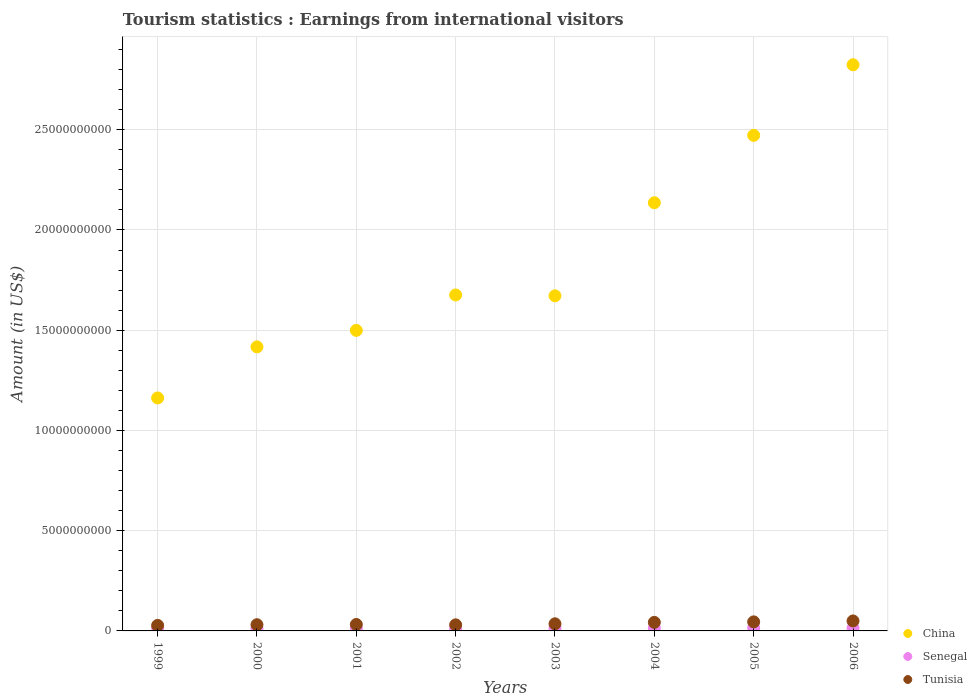How many different coloured dotlines are there?
Provide a succinct answer. 3. What is the earnings from international visitors in Tunisia in 2004?
Make the answer very short. 4.27e+08. Across all years, what is the maximum earnings from international visitors in China?
Your answer should be very brief. 2.82e+1. Across all years, what is the minimum earnings from international visitors in Tunisia?
Give a very brief answer. 2.76e+08. In which year was the earnings from international visitors in China maximum?
Your response must be concise. 2006. What is the total earnings from international visitors in China in the graph?
Give a very brief answer. 1.49e+11. What is the difference between the earnings from international visitors in Tunisia in 2000 and that in 2006?
Give a very brief answer. -1.88e+08. What is the difference between the earnings from international visitors in Tunisia in 2004 and the earnings from international visitors in Senegal in 2001?
Ensure brevity in your answer.  3.15e+08. What is the average earnings from international visitors in China per year?
Offer a terse response. 1.86e+1. In the year 2002, what is the difference between the earnings from international visitors in Tunisia and earnings from international visitors in Senegal?
Ensure brevity in your answer.  1.91e+08. In how many years, is the earnings from international visitors in China greater than 25000000000 US$?
Your answer should be very brief. 1. What is the ratio of the earnings from international visitors in Tunisia in 2001 to that in 2004?
Provide a short and direct response. 0.75. What is the difference between the highest and the second highest earnings from international visitors in Tunisia?
Make the answer very short. 4.60e+07. What is the difference between the highest and the lowest earnings from international visitors in China?
Your answer should be very brief. 1.66e+1. Does the earnings from international visitors in Senegal monotonically increase over the years?
Offer a very short reply. No. Is the earnings from international visitors in China strictly greater than the earnings from international visitors in Tunisia over the years?
Ensure brevity in your answer.  Yes. Is the earnings from international visitors in China strictly less than the earnings from international visitors in Senegal over the years?
Give a very brief answer. No. How many years are there in the graph?
Ensure brevity in your answer.  8. Does the graph contain grids?
Offer a very short reply. Yes. How many legend labels are there?
Give a very brief answer. 3. How are the legend labels stacked?
Your response must be concise. Vertical. What is the title of the graph?
Provide a short and direct response. Tourism statistics : Earnings from international visitors. What is the Amount (in US$) in China in 1999?
Your answer should be very brief. 1.16e+1. What is the Amount (in US$) of Senegal in 1999?
Your answer should be compact. 1.36e+08. What is the Amount (in US$) of Tunisia in 1999?
Provide a short and direct response. 2.76e+08. What is the Amount (in US$) of China in 2000?
Keep it short and to the point. 1.42e+1. What is the Amount (in US$) in Senegal in 2000?
Offer a terse response. 1.25e+08. What is the Amount (in US$) of Tunisia in 2000?
Make the answer very short. 3.10e+08. What is the Amount (in US$) of China in 2001?
Offer a very short reply. 1.50e+1. What is the Amount (in US$) in Senegal in 2001?
Ensure brevity in your answer.  1.12e+08. What is the Amount (in US$) of Tunisia in 2001?
Provide a short and direct response. 3.22e+08. What is the Amount (in US$) of China in 2002?
Provide a succinct answer. 1.68e+1. What is the Amount (in US$) in Senegal in 2002?
Make the answer very short. 1.12e+08. What is the Amount (in US$) of Tunisia in 2002?
Keep it short and to the point. 3.03e+08. What is the Amount (in US$) in China in 2003?
Keep it short and to the point. 1.67e+1. What is the Amount (in US$) of Senegal in 2003?
Ensure brevity in your answer.  1.29e+08. What is the Amount (in US$) of Tunisia in 2003?
Make the answer very short. 3.55e+08. What is the Amount (in US$) in China in 2004?
Your response must be concise. 2.14e+1. What is the Amount (in US$) in Senegal in 2004?
Provide a succinct answer. 1.38e+08. What is the Amount (in US$) of Tunisia in 2004?
Your response must be concise. 4.27e+08. What is the Amount (in US$) of China in 2005?
Ensure brevity in your answer.  2.47e+1. What is the Amount (in US$) of Senegal in 2005?
Your answer should be very brief. 1.44e+08. What is the Amount (in US$) in Tunisia in 2005?
Your answer should be very brief. 4.52e+08. What is the Amount (in US$) of China in 2006?
Give a very brief answer. 2.82e+1. What is the Amount (in US$) in Senegal in 2006?
Ensure brevity in your answer.  1.39e+08. What is the Amount (in US$) in Tunisia in 2006?
Your answer should be very brief. 4.98e+08. Across all years, what is the maximum Amount (in US$) in China?
Offer a very short reply. 2.82e+1. Across all years, what is the maximum Amount (in US$) of Senegal?
Offer a terse response. 1.44e+08. Across all years, what is the maximum Amount (in US$) in Tunisia?
Offer a terse response. 4.98e+08. Across all years, what is the minimum Amount (in US$) of China?
Offer a terse response. 1.16e+1. Across all years, what is the minimum Amount (in US$) in Senegal?
Your answer should be very brief. 1.12e+08. Across all years, what is the minimum Amount (in US$) of Tunisia?
Your answer should be very brief. 2.76e+08. What is the total Amount (in US$) of China in the graph?
Your response must be concise. 1.49e+11. What is the total Amount (in US$) in Senegal in the graph?
Give a very brief answer. 1.04e+09. What is the total Amount (in US$) of Tunisia in the graph?
Provide a short and direct response. 2.94e+09. What is the difference between the Amount (in US$) of China in 1999 and that in 2000?
Your response must be concise. -2.55e+09. What is the difference between the Amount (in US$) in Senegal in 1999 and that in 2000?
Your response must be concise. 1.10e+07. What is the difference between the Amount (in US$) of Tunisia in 1999 and that in 2000?
Your answer should be very brief. -3.40e+07. What is the difference between the Amount (in US$) in China in 1999 and that in 2001?
Your response must be concise. -3.37e+09. What is the difference between the Amount (in US$) of Senegal in 1999 and that in 2001?
Offer a terse response. 2.40e+07. What is the difference between the Amount (in US$) in Tunisia in 1999 and that in 2001?
Ensure brevity in your answer.  -4.60e+07. What is the difference between the Amount (in US$) of China in 1999 and that in 2002?
Your answer should be compact. -5.14e+09. What is the difference between the Amount (in US$) of Senegal in 1999 and that in 2002?
Offer a very short reply. 2.40e+07. What is the difference between the Amount (in US$) of Tunisia in 1999 and that in 2002?
Keep it short and to the point. -2.70e+07. What is the difference between the Amount (in US$) of China in 1999 and that in 2003?
Ensure brevity in your answer.  -5.10e+09. What is the difference between the Amount (in US$) in Tunisia in 1999 and that in 2003?
Keep it short and to the point. -7.90e+07. What is the difference between the Amount (in US$) of China in 1999 and that in 2004?
Your answer should be very brief. -9.74e+09. What is the difference between the Amount (in US$) of Tunisia in 1999 and that in 2004?
Provide a succinct answer. -1.51e+08. What is the difference between the Amount (in US$) in China in 1999 and that in 2005?
Give a very brief answer. -1.31e+1. What is the difference between the Amount (in US$) of Senegal in 1999 and that in 2005?
Offer a very short reply. -8.00e+06. What is the difference between the Amount (in US$) of Tunisia in 1999 and that in 2005?
Your answer should be very brief. -1.76e+08. What is the difference between the Amount (in US$) of China in 1999 and that in 2006?
Provide a short and direct response. -1.66e+1. What is the difference between the Amount (in US$) in Tunisia in 1999 and that in 2006?
Offer a very short reply. -2.22e+08. What is the difference between the Amount (in US$) in China in 2000 and that in 2001?
Offer a terse response. -8.23e+08. What is the difference between the Amount (in US$) in Senegal in 2000 and that in 2001?
Provide a succinct answer. 1.30e+07. What is the difference between the Amount (in US$) in Tunisia in 2000 and that in 2001?
Provide a succinct answer. -1.20e+07. What is the difference between the Amount (in US$) in China in 2000 and that in 2002?
Your answer should be compact. -2.59e+09. What is the difference between the Amount (in US$) of Senegal in 2000 and that in 2002?
Ensure brevity in your answer.  1.30e+07. What is the difference between the Amount (in US$) of Tunisia in 2000 and that in 2002?
Make the answer very short. 7.00e+06. What is the difference between the Amount (in US$) of China in 2000 and that in 2003?
Provide a short and direct response. -2.55e+09. What is the difference between the Amount (in US$) in Tunisia in 2000 and that in 2003?
Ensure brevity in your answer.  -4.50e+07. What is the difference between the Amount (in US$) in China in 2000 and that in 2004?
Offer a very short reply. -7.19e+09. What is the difference between the Amount (in US$) in Senegal in 2000 and that in 2004?
Offer a very short reply. -1.30e+07. What is the difference between the Amount (in US$) in Tunisia in 2000 and that in 2004?
Provide a succinct answer. -1.17e+08. What is the difference between the Amount (in US$) in China in 2000 and that in 2005?
Ensure brevity in your answer.  -1.06e+1. What is the difference between the Amount (in US$) in Senegal in 2000 and that in 2005?
Keep it short and to the point. -1.90e+07. What is the difference between the Amount (in US$) of Tunisia in 2000 and that in 2005?
Your response must be concise. -1.42e+08. What is the difference between the Amount (in US$) of China in 2000 and that in 2006?
Provide a succinct answer. -1.41e+1. What is the difference between the Amount (in US$) in Senegal in 2000 and that in 2006?
Your answer should be very brief. -1.40e+07. What is the difference between the Amount (in US$) in Tunisia in 2000 and that in 2006?
Provide a short and direct response. -1.88e+08. What is the difference between the Amount (in US$) in China in 2001 and that in 2002?
Offer a very short reply. -1.77e+09. What is the difference between the Amount (in US$) in Tunisia in 2001 and that in 2002?
Make the answer very short. 1.90e+07. What is the difference between the Amount (in US$) in China in 2001 and that in 2003?
Provide a succinct answer. -1.72e+09. What is the difference between the Amount (in US$) of Senegal in 2001 and that in 2003?
Keep it short and to the point. -1.70e+07. What is the difference between the Amount (in US$) of Tunisia in 2001 and that in 2003?
Provide a short and direct response. -3.30e+07. What is the difference between the Amount (in US$) of China in 2001 and that in 2004?
Provide a short and direct response. -6.37e+09. What is the difference between the Amount (in US$) of Senegal in 2001 and that in 2004?
Your answer should be very brief. -2.60e+07. What is the difference between the Amount (in US$) in Tunisia in 2001 and that in 2004?
Your response must be concise. -1.05e+08. What is the difference between the Amount (in US$) of China in 2001 and that in 2005?
Offer a very short reply. -9.73e+09. What is the difference between the Amount (in US$) in Senegal in 2001 and that in 2005?
Provide a short and direct response. -3.20e+07. What is the difference between the Amount (in US$) of Tunisia in 2001 and that in 2005?
Provide a succinct answer. -1.30e+08. What is the difference between the Amount (in US$) of China in 2001 and that in 2006?
Your answer should be very brief. -1.32e+1. What is the difference between the Amount (in US$) in Senegal in 2001 and that in 2006?
Keep it short and to the point. -2.70e+07. What is the difference between the Amount (in US$) of Tunisia in 2001 and that in 2006?
Provide a succinct answer. -1.76e+08. What is the difference between the Amount (in US$) of China in 2002 and that in 2003?
Offer a very short reply. 4.30e+07. What is the difference between the Amount (in US$) of Senegal in 2002 and that in 2003?
Provide a succinct answer. -1.70e+07. What is the difference between the Amount (in US$) in Tunisia in 2002 and that in 2003?
Your answer should be very brief. -5.20e+07. What is the difference between the Amount (in US$) of China in 2002 and that in 2004?
Provide a succinct answer. -4.60e+09. What is the difference between the Amount (in US$) of Senegal in 2002 and that in 2004?
Keep it short and to the point. -2.60e+07. What is the difference between the Amount (in US$) of Tunisia in 2002 and that in 2004?
Give a very brief answer. -1.24e+08. What is the difference between the Amount (in US$) in China in 2002 and that in 2005?
Offer a very short reply. -7.96e+09. What is the difference between the Amount (in US$) in Senegal in 2002 and that in 2005?
Offer a very short reply. -3.20e+07. What is the difference between the Amount (in US$) of Tunisia in 2002 and that in 2005?
Keep it short and to the point. -1.49e+08. What is the difference between the Amount (in US$) of China in 2002 and that in 2006?
Offer a terse response. -1.15e+1. What is the difference between the Amount (in US$) of Senegal in 2002 and that in 2006?
Offer a terse response. -2.70e+07. What is the difference between the Amount (in US$) in Tunisia in 2002 and that in 2006?
Give a very brief answer. -1.95e+08. What is the difference between the Amount (in US$) in China in 2003 and that in 2004?
Give a very brief answer. -4.64e+09. What is the difference between the Amount (in US$) in Senegal in 2003 and that in 2004?
Offer a terse response. -9.00e+06. What is the difference between the Amount (in US$) in Tunisia in 2003 and that in 2004?
Your answer should be very brief. -7.20e+07. What is the difference between the Amount (in US$) in China in 2003 and that in 2005?
Provide a short and direct response. -8.00e+09. What is the difference between the Amount (in US$) in Senegal in 2003 and that in 2005?
Your answer should be very brief. -1.50e+07. What is the difference between the Amount (in US$) in Tunisia in 2003 and that in 2005?
Provide a short and direct response. -9.70e+07. What is the difference between the Amount (in US$) in China in 2003 and that in 2006?
Provide a short and direct response. -1.15e+1. What is the difference between the Amount (in US$) in Senegal in 2003 and that in 2006?
Your answer should be very brief. -1.00e+07. What is the difference between the Amount (in US$) in Tunisia in 2003 and that in 2006?
Provide a succinct answer. -1.43e+08. What is the difference between the Amount (in US$) in China in 2004 and that in 2005?
Provide a succinct answer. -3.36e+09. What is the difference between the Amount (in US$) in Senegal in 2004 and that in 2005?
Provide a succinct answer. -6.00e+06. What is the difference between the Amount (in US$) in Tunisia in 2004 and that in 2005?
Ensure brevity in your answer.  -2.50e+07. What is the difference between the Amount (in US$) of China in 2004 and that in 2006?
Give a very brief answer. -6.88e+09. What is the difference between the Amount (in US$) in Tunisia in 2004 and that in 2006?
Offer a terse response. -7.10e+07. What is the difference between the Amount (in US$) in China in 2005 and that in 2006?
Your answer should be very brief. -3.52e+09. What is the difference between the Amount (in US$) of Senegal in 2005 and that in 2006?
Give a very brief answer. 5.00e+06. What is the difference between the Amount (in US$) in Tunisia in 2005 and that in 2006?
Your answer should be very brief. -4.60e+07. What is the difference between the Amount (in US$) of China in 1999 and the Amount (in US$) of Senegal in 2000?
Offer a terse response. 1.15e+1. What is the difference between the Amount (in US$) of China in 1999 and the Amount (in US$) of Tunisia in 2000?
Your answer should be compact. 1.13e+1. What is the difference between the Amount (in US$) of Senegal in 1999 and the Amount (in US$) of Tunisia in 2000?
Provide a short and direct response. -1.74e+08. What is the difference between the Amount (in US$) of China in 1999 and the Amount (in US$) of Senegal in 2001?
Offer a very short reply. 1.15e+1. What is the difference between the Amount (in US$) of China in 1999 and the Amount (in US$) of Tunisia in 2001?
Your answer should be very brief. 1.13e+1. What is the difference between the Amount (in US$) of Senegal in 1999 and the Amount (in US$) of Tunisia in 2001?
Offer a terse response. -1.86e+08. What is the difference between the Amount (in US$) in China in 1999 and the Amount (in US$) in Senegal in 2002?
Offer a terse response. 1.15e+1. What is the difference between the Amount (in US$) of China in 1999 and the Amount (in US$) of Tunisia in 2002?
Keep it short and to the point. 1.13e+1. What is the difference between the Amount (in US$) in Senegal in 1999 and the Amount (in US$) in Tunisia in 2002?
Ensure brevity in your answer.  -1.67e+08. What is the difference between the Amount (in US$) of China in 1999 and the Amount (in US$) of Senegal in 2003?
Your answer should be very brief. 1.15e+1. What is the difference between the Amount (in US$) of China in 1999 and the Amount (in US$) of Tunisia in 2003?
Offer a very short reply. 1.13e+1. What is the difference between the Amount (in US$) of Senegal in 1999 and the Amount (in US$) of Tunisia in 2003?
Provide a short and direct response. -2.19e+08. What is the difference between the Amount (in US$) in China in 1999 and the Amount (in US$) in Senegal in 2004?
Provide a short and direct response. 1.15e+1. What is the difference between the Amount (in US$) in China in 1999 and the Amount (in US$) in Tunisia in 2004?
Provide a short and direct response. 1.12e+1. What is the difference between the Amount (in US$) of Senegal in 1999 and the Amount (in US$) of Tunisia in 2004?
Your answer should be very brief. -2.91e+08. What is the difference between the Amount (in US$) of China in 1999 and the Amount (in US$) of Senegal in 2005?
Offer a very short reply. 1.15e+1. What is the difference between the Amount (in US$) in China in 1999 and the Amount (in US$) in Tunisia in 2005?
Provide a succinct answer. 1.12e+1. What is the difference between the Amount (in US$) of Senegal in 1999 and the Amount (in US$) of Tunisia in 2005?
Ensure brevity in your answer.  -3.16e+08. What is the difference between the Amount (in US$) in China in 1999 and the Amount (in US$) in Senegal in 2006?
Offer a terse response. 1.15e+1. What is the difference between the Amount (in US$) of China in 1999 and the Amount (in US$) of Tunisia in 2006?
Offer a very short reply. 1.11e+1. What is the difference between the Amount (in US$) in Senegal in 1999 and the Amount (in US$) in Tunisia in 2006?
Your answer should be very brief. -3.62e+08. What is the difference between the Amount (in US$) in China in 2000 and the Amount (in US$) in Senegal in 2001?
Provide a succinct answer. 1.41e+1. What is the difference between the Amount (in US$) in China in 2000 and the Amount (in US$) in Tunisia in 2001?
Offer a very short reply. 1.38e+1. What is the difference between the Amount (in US$) in Senegal in 2000 and the Amount (in US$) in Tunisia in 2001?
Your response must be concise. -1.97e+08. What is the difference between the Amount (in US$) in China in 2000 and the Amount (in US$) in Senegal in 2002?
Offer a very short reply. 1.41e+1. What is the difference between the Amount (in US$) of China in 2000 and the Amount (in US$) of Tunisia in 2002?
Your answer should be very brief. 1.39e+1. What is the difference between the Amount (in US$) in Senegal in 2000 and the Amount (in US$) in Tunisia in 2002?
Your response must be concise. -1.78e+08. What is the difference between the Amount (in US$) in China in 2000 and the Amount (in US$) in Senegal in 2003?
Your answer should be compact. 1.40e+1. What is the difference between the Amount (in US$) of China in 2000 and the Amount (in US$) of Tunisia in 2003?
Keep it short and to the point. 1.38e+1. What is the difference between the Amount (in US$) of Senegal in 2000 and the Amount (in US$) of Tunisia in 2003?
Your response must be concise. -2.30e+08. What is the difference between the Amount (in US$) of China in 2000 and the Amount (in US$) of Senegal in 2004?
Make the answer very short. 1.40e+1. What is the difference between the Amount (in US$) in China in 2000 and the Amount (in US$) in Tunisia in 2004?
Your answer should be very brief. 1.37e+1. What is the difference between the Amount (in US$) in Senegal in 2000 and the Amount (in US$) in Tunisia in 2004?
Give a very brief answer. -3.02e+08. What is the difference between the Amount (in US$) of China in 2000 and the Amount (in US$) of Senegal in 2005?
Make the answer very short. 1.40e+1. What is the difference between the Amount (in US$) in China in 2000 and the Amount (in US$) in Tunisia in 2005?
Provide a succinct answer. 1.37e+1. What is the difference between the Amount (in US$) of Senegal in 2000 and the Amount (in US$) of Tunisia in 2005?
Your answer should be compact. -3.27e+08. What is the difference between the Amount (in US$) in China in 2000 and the Amount (in US$) in Senegal in 2006?
Make the answer very short. 1.40e+1. What is the difference between the Amount (in US$) of China in 2000 and the Amount (in US$) of Tunisia in 2006?
Give a very brief answer. 1.37e+1. What is the difference between the Amount (in US$) in Senegal in 2000 and the Amount (in US$) in Tunisia in 2006?
Your answer should be very brief. -3.73e+08. What is the difference between the Amount (in US$) in China in 2001 and the Amount (in US$) in Senegal in 2002?
Provide a short and direct response. 1.49e+1. What is the difference between the Amount (in US$) in China in 2001 and the Amount (in US$) in Tunisia in 2002?
Make the answer very short. 1.47e+1. What is the difference between the Amount (in US$) of Senegal in 2001 and the Amount (in US$) of Tunisia in 2002?
Make the answer very short. -1.91e+08. What is the difference between the Amount (in US$) in China in 2001 and the Amount (in US$) in Senegal in 2003?
Make the answer very short. 1.49e+1. What is the difference between the Amount (in US$) in China in 2001 and the Amount (in US$) in Tunisia in 2003?
Provide a succinct answer. 1.46e+1. What is the difference between the Amount (in US$) in Senegal in 2001 and the Amount (in US$) in Tunisia in 2003?
Ensure brevity in your answer.  -2.43e+08. What is the difference between the Amount (in US$) in China in 2001 and the Amount (in US$) in Senegal in 2004?
Provide a succinct answer. 1.49e+1. What is the difference between the Amount (in US$) of China in 2001 and the Amount (in US$) of Tunisia in 2004?
Keep it short and to the point. 1.46e+1. What is the difference between the Amount (in US$) of Senegal in 2001 and the Amount (in US$) of Tunisia in 2004?
Make the answer very short. -3.15e+08. What is the difference between the Amount (in US$) in China in 2001 and the Amount (in US$) in Senegal in 2005?
Provide a succinct answer. 1.48e+1. What is the difference between the Amount (in US$) in China in 2001 and the Amount (in US$) in Tunisia in 2005?
Provide a succinct answer. 1.45e+1. What is the difference between the Amount (in US$) in Senegal in 2001 and the Amount (in US$) in Tunisia in 2005?
Your answer should be very brief. -3.40e+08. What is the difference between the Amount (in US$) in China in 2001 and the Amount (in US$) in Senegal in 2006?
Provide a short and direct response. 1.49e+1. What is the difference between the Amount (in US$) of China in 2001 and the Amount (in US$) of Tunisia in 2006?
Make the answer very short. 1.45e+1. What is the difference between the Amount (in US$) of Senegal in 2001 and the Amount (in US$) of Tunisia in 2006?
Your response must be concise. -3.86e+08. What is the difference between the Amount (in US$) in China in 2002 and the Amount (in US$) in Senegal in 2003?
Your response must be concise. 1.66e+1. What is the difference between the Amount (in US$) of China in 2002 and the Amount (in US$) of Tunisia in 2003?
Keep it short and to the point. 1.64e+1. What is the difference between the Amount (in US$) in Senegal in 2002 and the Amount (in US$) in Tunisia in 2003?
Your answer should be compact. -2.43e+08. What is the difference between the Amount (in US$) of China in 2002 and the Amount (in US$) of Senegal in 2004?
Provide a short and direct response. 1.66e+1. What is the difference between the Amount (in US$) of China in 2002 and the Amount (in US$) of Tunisia in 2004?
Keep it short and to the point. 1.63e+1. What is the difference between the Amount (in US$) of Senegal in 2002 and the Amount (in US$) of Tunisia in 2004?
Your answer should be very brief. -3.15e+08. What is the difference between the Amount (in US$) of China in 2002 and the Amount (in US$) of Senegal in 2005?
Your answer should be very brief. 1.66e+1. What is the difference between the Amount (in US$) of China in 2002 and the Amount (in US$) of Tunisia in 2005?
Your response must be concise. 1.63e+1. What is the difference between the Amount (in US$) of Senegal in 2002 and the Amount (in US$) of Tunisia in 2005?
Your response must be concise. -3.40e+08. What is the difference between the Amount (in US$) in China in 2002 and the Amount (in US$) in Senegal in 2006?
Your answer should be very brief. 1.66e+1. What is the difference between the Amount (in US$) of China in 2002 and the Amount (in US$) of Tunisia in 2006?
Your answer should be very brief. 1.63e+1. What is the difference between the Amount (in US$) in Senegal in 2002 and the Amount (in US$) in Tunisia in 2006?
Make the answer very short. -3.86e+08. What is the difference between the Amount (in US$) in China in 2003 and the Amount (in US$) in Senegal in 2004?
Your answer should be very brief. 1.66e+1. What is the difference between the Amount (in US$) of China in 2003 and the Amount (in US$) of Tunisia in 2004?
Provide a short and direct response. 1.63e+1. What is the difference between the Amount (in US$) of Senegal in 2003 and the Amount (in US$) of Tunisia in 2004?
Keep it short and to the point. -2.98e+08. What is the difference between the Amount (in US$) of China in 2003 and the Amount (in US$) of Senegal in 2005?
Offer a very short reply. 1.66e+1. What is the difference between the Amount (in US$) of China in 2003 and the Amount (in US$) of Tunisia in 2005?
Give a very brief answer. 1.63e+1. What is the difference between the Amount (in US$) of Senegal in 2003 and the Amount (in US$) of Tunisia in 2005?
Offer a terse response. -3.23e+08. What is the difference between the Amount (in US$) of China in 2003 and the Amount (in US$) of Senegal in 2006?
Give a very brief answer. 1.66e+1. What is the difference between the Amount (in US$) of China in 2003 and the Amount (in US$) of Tunisia in 2006?
Your response must be concise. 1.62e+1. What is the difference between the Amount (in US$) in Senegal in 2003 and the Amount (in US$) in Tunisia in 2006?
Your response must be concise. -3.69e+08. What is the difference between the Amount (in US$) in China in 2004 and the Amount (in US$) in Senegal in 2005?
Your answer should be compact. 2.12e+1. What is the difference between the Amount (in US$) of China in 2004 and the Amount (in US$) of Tunisia in 2005?
Provide a succinct answer. 2.09e+1. What is the difference between the Amount (in US$) of Senegal in 2004 and the Amount (in US$) of Tunisia in 2005?
Make the answer very short. -3.14e+08. What is the difference between the Amount (in US$) in China in 2004 and the Amount (in US$) in Senegal in 2006?
Provide a succinct answer. 2.12e+1. What is the difference between the Amount (in US$) in China in 2004 and the Amount (in US$) in Tunisia in 2006?
Your response must be concise. 2.09e+1. What is the difference between the Amount (in US$) of Senegal in 2004 and the Amount (in US$) of Tunisia in 2006?
Offer a very short reply. -3.60e+08. What is the difference between the Amount (in US$) in China in 2005 and the Amount (in US$) in Senegal in 2006?
Your response must be concise. 2.46e+1. What is the difference between the Amount (in US$) in China in 2005 and the Amount (in US$) in Tunisia in 2006?
Your answer should be compact. 2.42e+1. What is the difference between the Amount (in US$) of Senegal in 2005 and the Amount (in US$) of Tunisia in 2006?
Your answer should be compact. -3.54e+08. What is the average Amount (in US$) of China per year?
Your answer should be very brief. 1.86e+1. What is the average Amount (in US$) in Senegal per year?
Provide a succinct answer. 1.29e+08. What is the average Amount (in US$) of Tunisia per year?
Offer a terse response. 3.68e+08. In the year 1999, what is the difference between the Amount (in US$) of China and Amount (in US$) of Senegal?
Ensure brevity in your answer.  1.15e+1. In the year 1999, what is the difference between the Amount (in US$) of China and Amount (in US$) of Tunisia?
Offer a very short reply. 1.13e+1. In the year 1999, what is the difference between the Amount (in US$) of Senegal and Amount (in US$) of Tunisia?
Offer a terse response. -1.40e+08. In the year 2000, what is the difference between the Amount (in US$) in China and Amount (in US$) in Senegal?
Keep it short and to the point. 1.40e+1. In the year 2000, what is the difference between the Amount (in US$) of China and Amount (in US$) of Tunisia?
Ensure brevity in your answer.  1.39e+1. In the year 2000, what is the difference between the Amount (in US$) of Senegal and Amount (in US$) of Tunisia?
Make the answer very short. -1.85e+08. In the year 2001, what is the difference between the Amount (in US$) in China and Amount (in US$) in Senegal?
Ensure brevity in your answer.  1.49e+1. In the year 2001, what is the difference between the Amount (in US$) of China and Amount (in US$) of Tunisia?
Ensure brevity in your answer.  1.47e+1. In the year 2001, what is the difference between the Amount (in US$) in Senegal and Amount (in US$) in Tunisia?
Ensure brevity in your answer.  -2.10e+08. In the year 2002, what is the difference between the Amount (in US$) in China and Amount (in US$) in Senegal?
Offer a very short reply. 1.66e+1. In the year 2002, what is the difference between the Amount (in US$) in China and Amount (in US$) in Tunisia?
Offer a very short reply. 1.65e+1. In the year 2002, what is the difference between the Amount (in US$) of Senegal and Amount (in US$) of Tunisia?
Give a very brief answer. -1.91e+08. In the year 2003, what is the difference between the Amount (in US$) of China and Amount (in US$) of Senegal?
Keep it short and to the point. 1.66e+1. In the year 2003, what is the difference between the Amount (in US$) of China and Amount (in US$) of Tunisia?
Your response must be concise. 1.64e+1. In the year 2003, what is the difference between the Amount (in US$) of Senegal and Amount (in US$) of Tunisia?
Your response must be concise. -2.26e+08. In the year 2004, what is the difference between the Amount (in US$) of China and Amount (in US$) of Senegal?
Provide a short and direct response. 2.12e+1. In the year 2004, what is the difference between the Amount (in US$) in China and Amount (in US$) in Tunisia?
Keep it short and to the point. 2.09e+1. In the year 2004, what is the difference between the Amount (in US$) in Senegal and Amount (in US$) in Tunisia?
Make the answer very short. -2.89e+08. In the year 2005, what is the difference between the Amount (in US$) in China and Amount (in US$) in Senegal?
Provide a short and direct response. 2.46e+1. In the year 2005, what is the difference between the Amount (in US$) in China and Amount (in US$) in Tunisia?
Provide a short and direct response. 2.43e+1. In the year 2005, what is the difference between the Amount (in US$) in Senegal and Amount (in US$) in Tunisia?
Keep it short and to the point. -3.08e+08. In the year 2006, what is the difference between the Amount (in US$) of China and Amount (in US$) of Senegal?
Keep it short and to the point. 2.81e+1. In the year 2006, what is the difference between the Amount (in US$) of China and Amount (in US$) of Tunisia?
Keep it short and to the point. 2.77e+1. In the year 2006, what is the difference between the Amount (in US$) in Senegal and Amount (in US$) in Tunisia?
Your response must be concise. -3.59e+08. What is the ratio of the Amount (in US$) of China in 1999 to that in 2000?
Make the answer very short. 0.82. What is the ratio of the Amount (in US$) of Senegal in 1999 to that in 2000?
Your answer should be compact. 1.09. What is the ratio of the Amount (in US$) in Tunisia in 1999 to that in 2000?
Your answer should be compact. 0.89. What is the ratio of the Amount (in US$) of China in 1999 to that in 2001?
Ensure brevity in your answer.  0.78. What is the ratio of the Amount (in US$) in Senegal in 1999 to that in 2001?
Offer a very short reply. 1.21. What is the ratio of the Amount (in US$) of China in 1999 to that in 2002?
Your response must be concise. 0.69. What is the ratio of the Amount (in US$) of Senegal in 1999 to that in 2002?
Your response must be concise. 1.21. What is the ratio of the Amount (in US$) of Tunisia in 1999 to that in 2002?
Ensure brevity in your answer.  0.91. What is the ratio of the Amount (in US$) in China in 1999 to that in 2003?
Your response must be concise. 0.7. What is the ratio of the Amount (in US$) in Senegal in 1999 to that in 2003?
Offer a very short reply. 1.05. What is the ratio of the Amount (in US$) of Tunisia in 1999 to that in 2003?
Your answer should be compact. 0.78. What is the ratio of the Amount (in US$) of China in 1999 to that in 2004?
Give a very brief answer. 0.54. What is the ratio of the Amount (in US$) in Senegal in 1999 to that in 2004?
Ensure brevity in your answer.  0.99. What is the ratio of the Amount (in US$) in Tunisia in 1999 to that in 2004?
Offer a terse response. 0.65. What is the ratio of the Amount (in US$) of China in 1999 to that in 2005?
Your answer should be compact. 0.47. What is the ratio of the Amount (in US$) in Tunisia in 1999 to that in 2005?
Offer a very short reply. 0.61. What is the ratio of the Amount (in US$) of China in 1999 to that in 2006?
Make the answer very short. 0.41. What is the ratio of the Amount (in US$) in Senegal in 1999 to that in 2006?
Offer a very short reply. 0.98. What is the ratio of the Amount (in US$) of Tunisia in 1999 to that in 2006?
Your response must be concise. 0.55. What is the ratio of the Amount (in US$) of China in 2000 to that in 2001?
Offer a very short reply. 0.95. What is the ratio of the Amount (in US$) in Senegal in 2000 to that in 2001?
Ensure brevity in your answer.  1.12. What is the ratio of the Amount (in US$) of Tunisia in 2000 to that in 2001?
Provide a short and direct response. 0.96. What is the ratio of the Amount (in US$) in China in 2000 to that in 2002?
Ensure brevity in your answer.  0.85. What is the ratio of the Amount (in US$) in Senegal in 2000 to that in 2002?
Your response must be concise. 1.12. What is the ratio of the Amount (in US$) of Tunisia in 2000 to that in 2002?
Your answer should be compact. 1.02. What is the ratio of the Amount (in US$) in China in 2000 to that in 2003?
Offer a terse response. 0.85. What is the ratio of the Amount (in US$) of Tunisia in 2000 to that in 2003?
Offer a very short reply. 0.87. What is the ratio of the Amount (in US$) of China in 2000 to that in 2004?
Provide a succinct answer. 0.66. What is the ratio of the Amount (in US$) of Senegal in 2000 to that in 2004?
Give a very brief answer. 0.91. What is the ratio of the Amount (in US$) of Tunisia in 2000 to that in 2004?
Provide a short and direct response. 0.73. What is the ratio of the Amount (in US$) in China in 2000 to that in 2005?
Give a very brief answer. 0.57. What is the ratio of the Amount (in US$) in Senegal in 2000 to that in 2005?
Offer a terse response. 0.87. What is the ratio of the Amount (in US$) in Tunisia in 2000 to that in 2005?
Offer a very short reply. 0.69. What is the ratio of the Amount (in US$) of China in 2000 to that in 2006?
Provide a short and direct response. 0.5. What is the ratio of the Amount (in US$) in Senegal in 2000 to that in 2006?
Offer a terse response. 0.9. What is the ratio of the Amount (in US$) of Tunisia in 2000 to that in 2006?
Your answer should be very brief. 0.62. What is the ratio of the Amount (in US$) in China in 2001 to that in 2002?
Provide a short and direct response. 0.89. What is the ratio of the Amount (in US$) of Tunisia in 2001 to that in 2002?
Make the answer very short. 1.06. What is the ratio of the Amount (in US$) of China in 2001 to that in 2003?
Provide a succinct answer. 0.9. What is the ratio of the Amount (in US$) in Senegal in 2001 to that in 2003?
Give a very brief answer. 0.87. What is the ratio of the Amount (in US$) in Tunisia in 2001 to that in 2003?
Provide a succinct answer. 0.91. What is the ratio of the Amount (in US$) in China in 2001 to that in 2004?
Offer a terse response. 0.7. What is the ratio of the Amount (in US$) in Senegal in 2001 to that in 2004?
Offer a very short reply. 0.81. What is the ratio of the Amount (in US$) of Tunisia in 2001 to that in 2004?
Offer a very short reply. 0.75. What is the ratio of the Amount (in US$) in China in 2001 to that in 2005?
Keep it short and to the point. 0.61. What is the ratio of the Amount (in US$) in Senegal in 2001 to that in 2005?
Keep it short and to the point. 0.78. What is the ratio of the Amount (in US$) in Tunisia in 2001 to that in 2005?
Provide a short and direct response. 0.71. What is the ratio of the Amount (in US$) of China in 2001 to that in 2006?
Offer a very short reply. 0.53. What is the ratio of the Amount (in US$) in Senegal in 2001 to that in 2006?
Make the answer very short. 0.81. What is the ratio of the Amount (in US$) of Tunisia in 2001 to that in 2006?
Offer a terse response. 0.65. What is the ratio of the Amount (in US$) of China in 2002 to that in 2003?
Provide a succinct answer. 1. What is the ratio of the Amount (in US$) in Senegal in 2002 to that in 2003?
Provide a succinct answer. 0.87. What is the ratio of the Amount (in US$) in Tunisia in 2002 to that in 2003?
Offer a very short reply. 0.85. What is the ratio of the Amount (in US$) in China in 2002 to that in 2004?
Your answer should be very brief. 0.78. What is the ratio of the Amount (in US$) of Senegal in 2002 to that in 2004?
Provide a short and direct response. 0.81. What is the ratio of the Amount (in US$) of Tunisia in 2002 to that in 2004?
Your response must be concise. 0.71. What is the ratio of the Amount (in US$) of China in 2002 to that in 2005?
Provide a short and direct response. 0.68. What is the ratio of the Amount (in US$) of Senegal in 2002 to that in 2005?
Offer a terse response. 0.78. What is the ratio of the Amount (in US$) in Tunisia in 2002 to that in 2005?
Your answer should be compact. 0.67. What is the ratio of the Amount (in US$) in China in 2002 to that in 2006?
Make the answer very short. 0.59. What is the ratio of the Amount (in US$) of Senegal in 2002 to that in 2006?
Ensure brevity in your answer.  0.81. What is the ratio of the Amount (in US$) of Tunisia in 2002 to that in 2006?
Keep it short and to the point. 0.61. What is the ratio of the Amount (in US$) of China in 2003 to that in 2004?
Provide a succinct answer. 0.78. What is the ratio of the Amount (in US$) of Senegal in 2003 to that in 2004?
Offer a very short reply. 0.93. What is the ratio of the Amount (in US$) of Tunisia in 2003 to that in 2004?
Offer a very short reply. 0.83. What is the ratio of the Amount (in US$) in China in 2003 to that in 2005?
Provide a short and direct response. 0.68. What is the ratio of the Amount (in US$) in Senegal in 2003 to that in 2005?
Keep it short and to the point. 0.9. What is the ratio of the Amount (in US$) of Tunisia in 2003 to that in 2005?
Ensure brevity in your answer.  0.79. What is the ratio of the Amount (in US$) in China in 2003 to that in 2006?
Your answer should be compact. 0.59. What is the ratio of the Amount (in US$) in Senegal in 2003 to that in 2006?
Give a very brief answer. 0.93. What is the ratio of the Amount (in US$) of Tunisia in 2003 to that in 2006?
Provide a succinct answer. 0.71. What is the ratio of the Amount (in US$) in China in 2004 to that in 2005?
Provide a short and direct response. 0.86. What is the ratio of the Amount (in US$) of Tunisia in 2004 to that in 2005?
Give a very brief answer. 0.94. What is the ratio of the Amount (in US$) in China in 2004 to that in 2006?
Your answer should be compact. 0.76. What is the ratio of the Amount (in US$) of Senegal in 2004 to that in 2006?
Offer a terse response. 0.99. What is the ratio of the Amount (in US$) in Tunisia in 2004 to that in 2006?
Your answer should be very brief. 0.86. What is the ratio of the Amount (in US$) in China in 2005 to that in 2006?
Your response must be concise. 0.88. What is the ratio of the Amount (in US$) of Senegal in 2005 to that in 2006?
Ensure brevity in your answer.  1.04. What is the ratio of the Amount (in US$) in Tunisia in 2005 to that in 2006?
Offer a terse response. 0.91. What is the difference between the highest and the second highest Amount (in US$) of China?
Offer a very short reply. 3.52e+09. What is the difference between the highest and the second highest Amount (in US$) in Senegal?
Give a very brief answer. 5.00e+06. What is the difference between the highest and the second highest Amount (in US$) of Tunisia?
Offer a terse response. 4.60e+07. What is the difference between the highest and the lowest Amount (in US$) in China?
Provide a succinct answer. 1.66e+1. What is the difference between the highest and the lowest Amount (in US$) of Senegal?
Ensure brevity in your answer.  3.20e+07. What is the difference between the highest and the lowest Amount (in US$) in Tunisia?
Offer a terse response. 2.22e+08. 